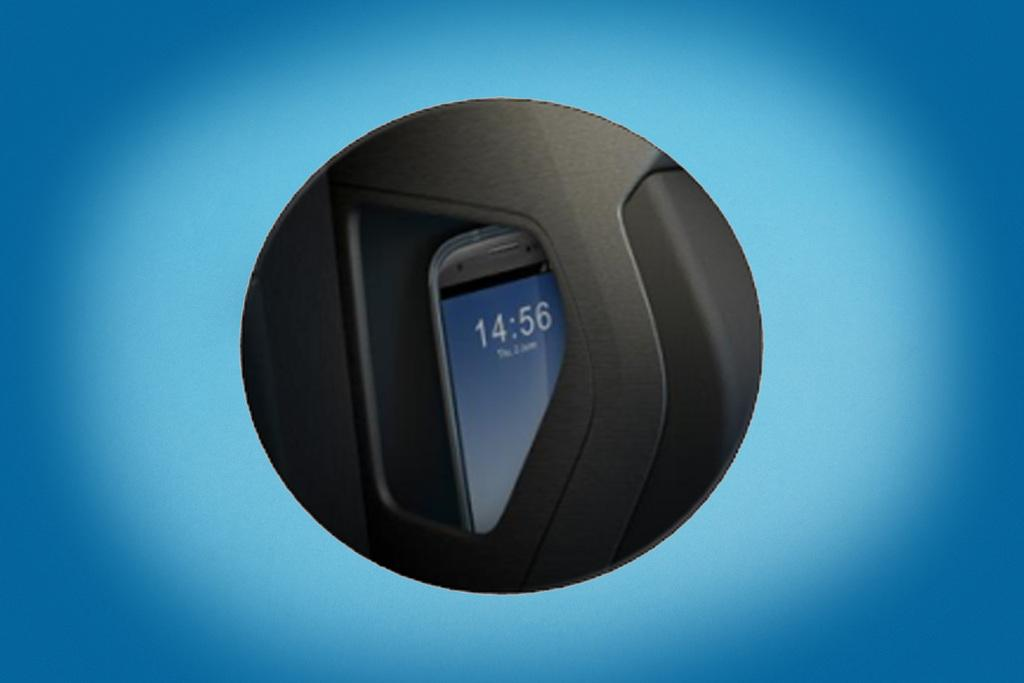<image>
Relay a brief, clear account of the picture shown. A phone has the time 14:56 on the screen. 